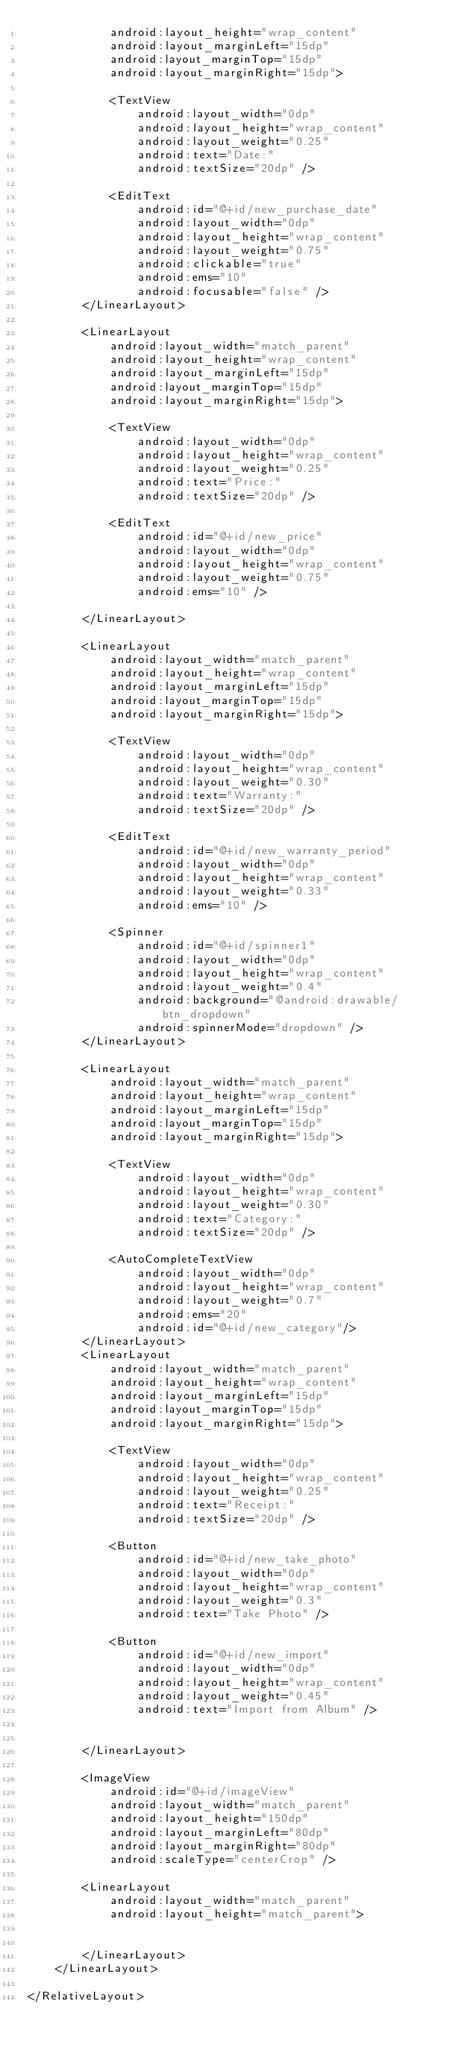<code> <loc_0><loc_0><loc_500><loc_500><_XML_>            android:layout_height="wrap_content"
            android:layout_marginLeft="15dp"
            android:layout_marginTop="15dp"
            android:layout_marginRight="15dp">

            <TextView
                android:layout_width="0dp"
                android:layout_height="wrap_content"
                android:layout_weight="0.25"
                android:text="Date:"
                android:textSize="20dp" />

            <EditText
                android:id="@+id/new_purchase_date"
                android:layout_width="0dp"
                android:layout_height="wrap_content"
                android:layout_weight="0.75"
                android:clickable="true"
                android:ems="10"
                android:focusable="false" />
        </LinearLayout>

        <LinearLayout
            android:layout_width="match_parent"
            android:layout_height="wrap_content"
            android:layout_marginLeft="15dp"
            android:layout_marginTop="15dp"
            android:layout_marginRight="15dp">

            <TextView
                android:layout_width="0dp"
                android:layout_height="wrap_content"
                android:layout_weight="0.25"
                android:text="Price:"
                android:textSize="20dp" />

            <EditText
                android:id="@+id/new_price"
                android:layout_width="0dp"
                android:layout_height="wrap_content"
                android:layout_weight="0.75"
                android:ems="10" />

        </LinearLayout>

        <LinearLayout
            android:layout_width="match_parent"
            android:layout_height="wrap_content"
            android:layout_marginLeft="15dp"
            android:layout_marginTop="15dp"
            android:layout_marginRight="15dp">

            <TextView
                android:layout_width="0dp"
                android:layout_height="wrap_content"
                android:layout_weight="0.30"
                android:text="Warranty:"
                android:textSize="20dp" />

            <EditText
                android:id="@+id/new_warranty_period"
                android:layout_width="0dp"
                android:layout_height="wrap_content"
                android:layout_weight="0.33"
                android:ems="10" />

            <Spinner
                android:id="@+id/spinner1"
                android:layout_width="0dp"
                android:layout_height="wrap_content"
                android:layout_weight="0.4"
                android:background="@android:drawable/btn_dropdown"
                android:spinnerMode="dropdown" />
        </LinearLayout>

        <LinearLayout
            android:layout_width="match_parent"
            android:layout_height="wrap_content"
            android:layout_marginLeft="15dp"
            android:layout_marginTop="15dp"
            android:layout_marginRight="15dp">

            <TextView
                android:layout_width="0dp"
                android:layout_height="wrap_content"
                android:layout_weight="0.30"
                android:text="Category:"
                android:textSize="20dp" />

            <AutoCompleteTextView
                android:layout_width="0dp"
                android:layout_height="wrap_content"
                android:layout_weight="0.7"
                android:ems="20"
                android:id="@+id/new_category"/>
        </LinearLayout>
        <LinearLayout
            android:layout_width="match_parent"
            android:layout_height="wrap_content"
            android:layout_marginLeft="15dp"
            android:layout_marginTop="15dp"
            android:layout_marginRight="15dp">

            <TextView
                android:layout_width="0dp"
                android:layout_height="wrap_content"
                android:layout_weight="0.25"
                android:text="Receipt:"
                android:textSize="20dp" />

            <Button
                android:id="@+id/new_take_photo"
                android:layout_width="0dp"
                android:layout_height="wrap_content"
                android:layout_weight="0.3"
                android:text="Take Photo" />

            <Button
                android:id="@+id/new_import"
                android:layout_width="0dp"
                android:layout_height="wrap_content"
                android:layout_weight="0.45"
                android:text="Import from Album" />


        </LinearLayout>

        <ImageView
            android:id="@+id/imageView"
            android:layout_width="match_parent"
            android:layout_height="150dp"
            android:layout_marginLeft="80dp"
            android:layout_marginRight="80dp"
            android:scaleType="centerCrop" />

        <LinearLayout
            android:layout_width="match_parent"
            android:layout_height="match_parent">


        </LinearLayout>
    </LinearLayout>

</RelativeLayout></code> 